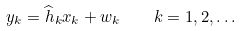<formula> <loc_0><loc_0><loc_500><loc_500>y _ { k } = \widehat { h } _ { k } x _ { k } + w _ { k } \quad k = 1 , 2 , \dots</formula> 